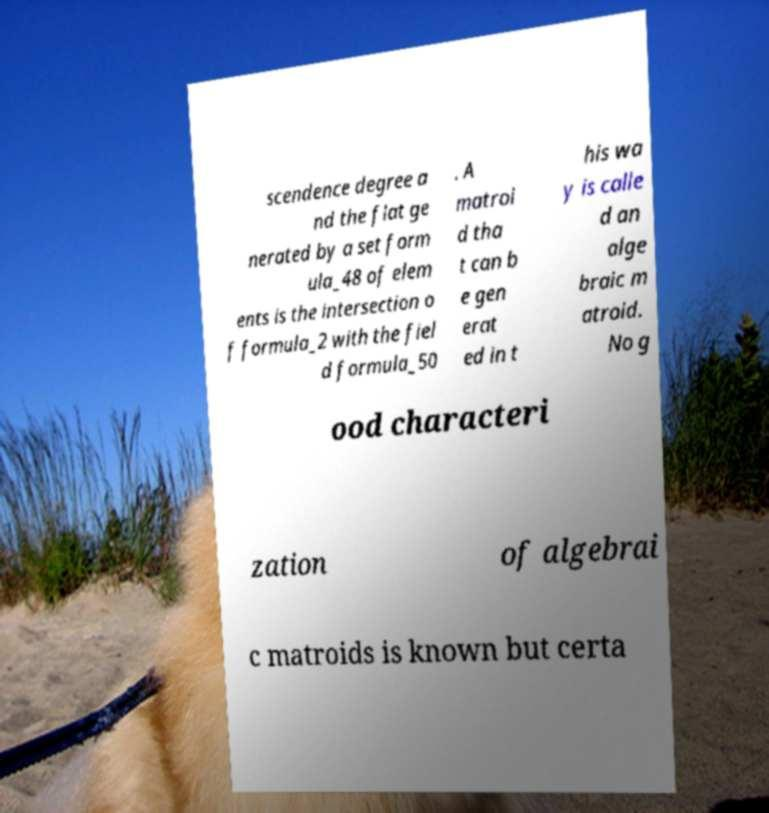I need the written content from this picture converted into text. Can you do that? scendence degree a nd the flat ge nerated by a set form ula_48 of elem ents is the intersection o f formula_2 with the fiel d formula_50 . A matroi d tha t can b e gen erat ed in t his wa y is calle d an alge braic m atroid. No g ood characteri zation of algebrai c matroids is known but certa 